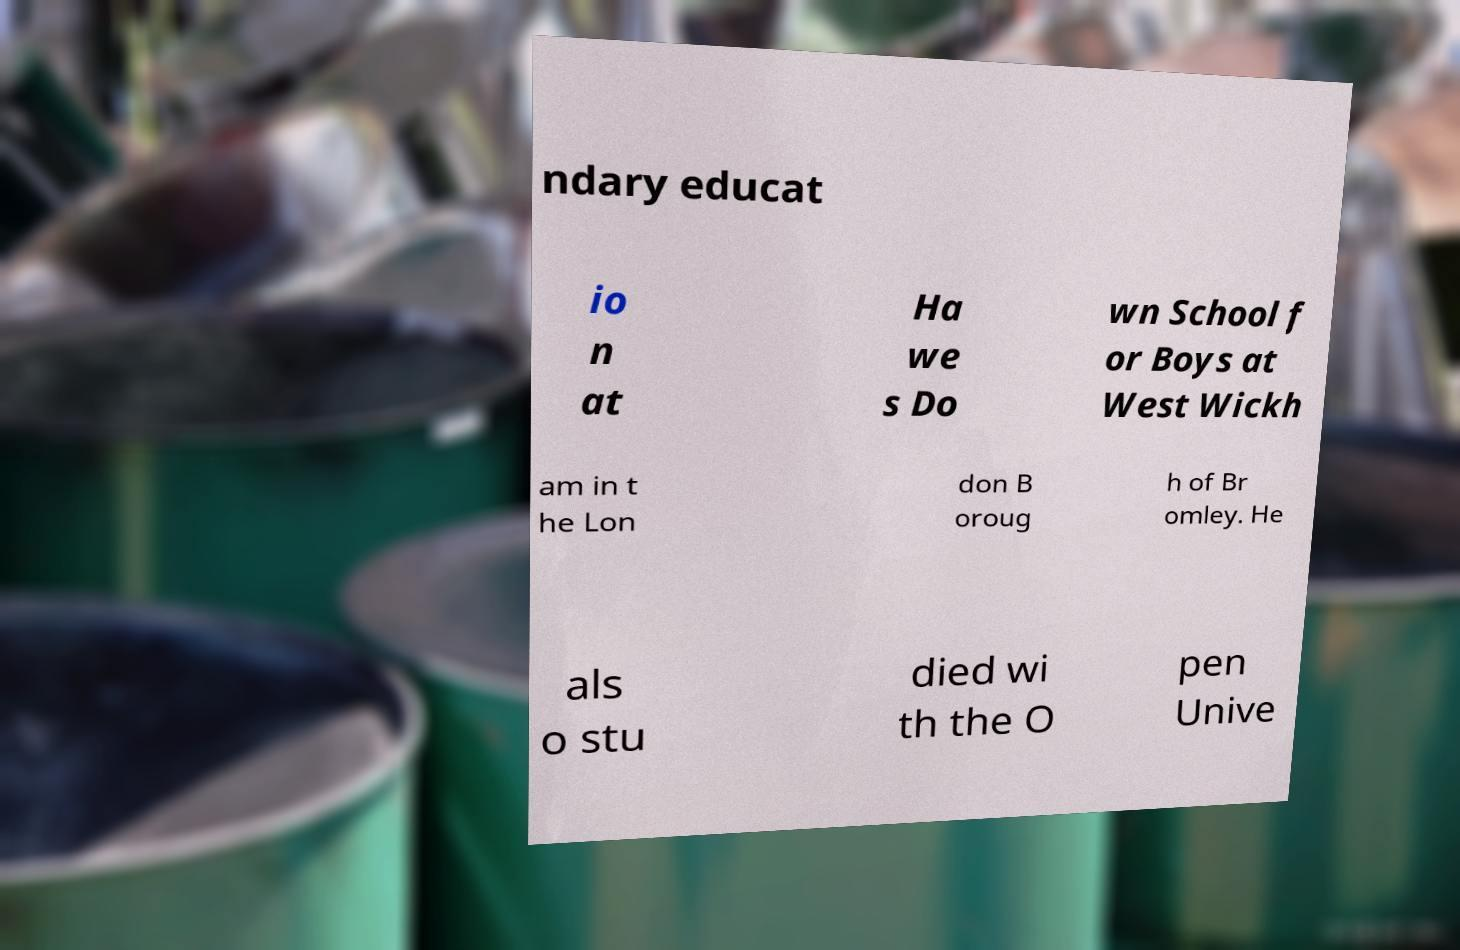There's text embedded in this image that I need extracted. Can you transcribe it verbatim? ndary educat io n at Ha we s Do wn School f or Boys at West Wickh am in t he Lon don B oroug h of Br omley. He als o stu died wi th the O pen Unive 